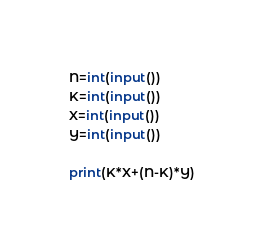<code> <loc_0><loc_0><loc_500><loc_500><_Python_>N=int(input())
K=int(input())
X=int(input())
Y=int(input())

print(K*X+(N-K)*Y)</code> 